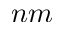<formula> <loc_0><loc_0><loc_500><loc_500>n m</formula> 